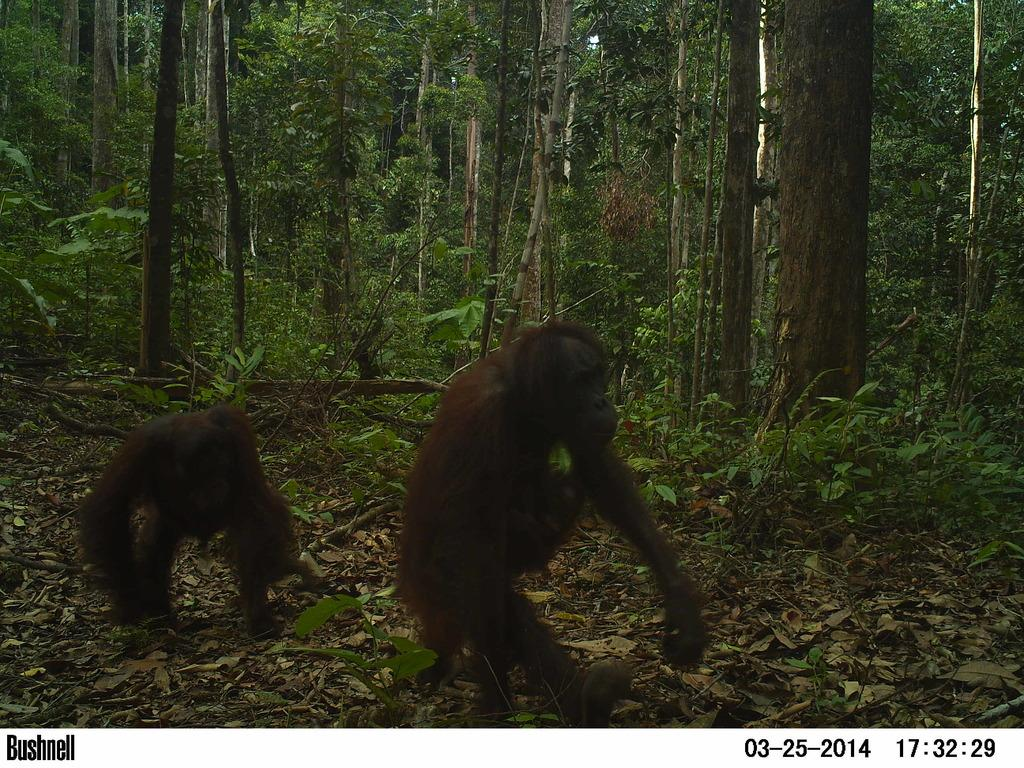How many chimpanzees are in the image? There are two chimpanzees in the image. What is the setting of the image? The chimpanzees are in a forest setting. What can be seen in the background of the image? There are plants and trees visible in the background of the image. What type of pin can be seen holding the chimpanzees together in the image? There is no pin present in the image; the chimpanzees are not physically connected. Is the forest setting in the image covered with quicksand? There is no mention of quicksand in the image, and it cannot be determined from the provided facts. 